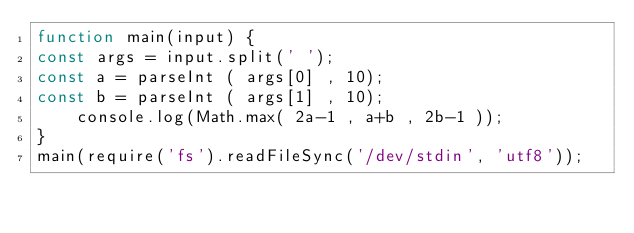Convert code to text. <code><loc_0><loc_0><loc_500><loc_500><_JavaScript_>function main(input) {
const args = input.split(' ');
const a = parseInt ( args[0] , 10);
const b = parseInt ( args[1] , 10);
    console.log(Math.max( 2a-1 , a+b , 2b-1 ));
}
main(require('fs').readFileSync('/dev/stdin', 'utf8'));
</code> 